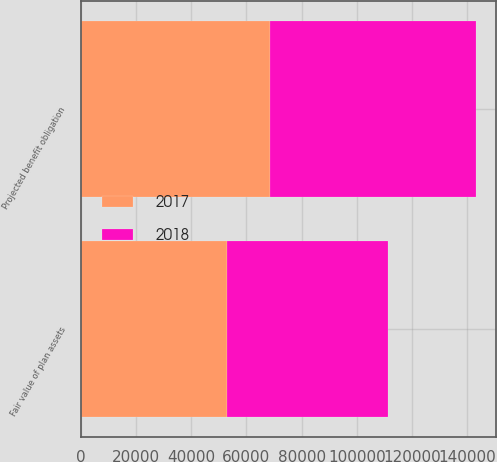Convert chart to OTSL. <chart><loc_0><loc_0><loc_500><loc_500><stacked_bar_chart><ecel><fcel>Projected benefit obligation<fcel>Fair value of plan assets<nl><fcel>2017<fcel>68354<fcel>52894<nl><fcel>2018<fcel>74953<fcel>58353<nl></chart> 